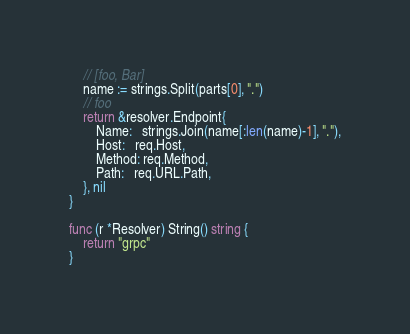Convert code to text. <code><loc_0><loc_0><loc_500><loc_500><_Go_>	// [foo, Bar]
	name := strings.Split(parts[0], ".")
	// foo
	return &resolver.Endpoint{
		Name:   strings.Join(name[:len(name)-1], "."),
		Host:   req.Host,
		Method: req.Method,
		Path:   req.URL.Path,
	}, nil
}

func (r *Resolver) String() string {
	return "grpc"
}
</code> 